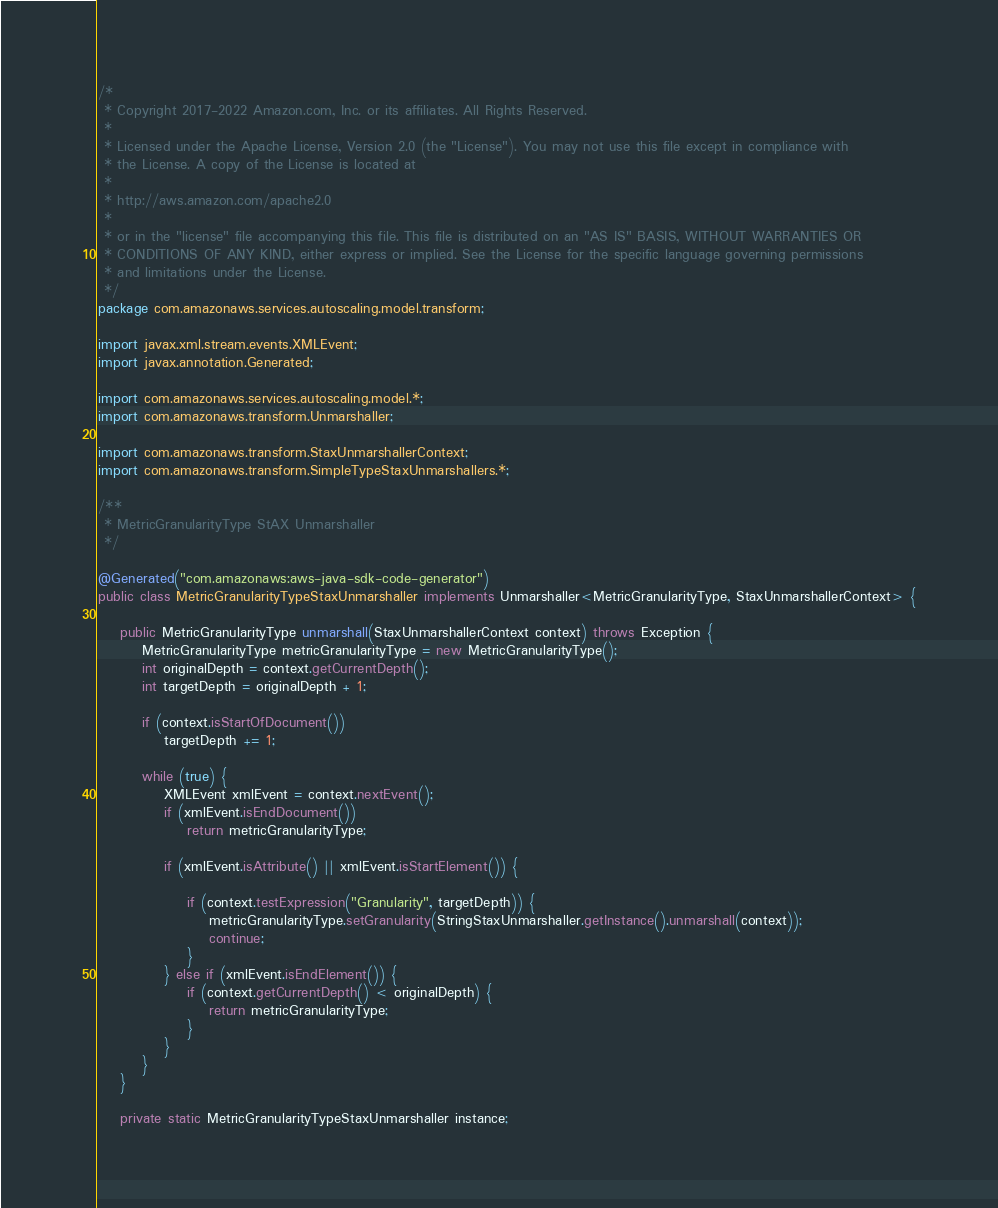Convert code to text. <code><loc_0><loc_0><loc_500><loc_500><_Java_>/*
 * Copyright 2017-2022 Amazon.com, Inc. or its affiliates. All Rights Reserved.
 * 
 * Licensed under the Apache License, Version 2.0 (the "License"). You may not use this file except in compliance with
 * the License. A copy of the License is located at
 * 
 * http://aws.amazon.com/apache2.0
 * 
 * or in the "license" file accompanying this file. This file is distributed on an "AS IS" BASIS, WITHOUT WARRANTIES OR
 * CONDITIONS OF ANY KIND, either express or implied. See the License for the specific language governing permissions
 * and limitations under the License.
 */
package com.amazonaws.services.autoscaling.model.transform;

import javax.xml.stream.events.XMLEvent;
import javax.annotation.Generated;

import com.amazonaws.services.autoscaling.model.*;
import com.amazonaws.transform.Unmarshaller;

import com.amazonaws.transform.StaxUnmarshallerContext;
import com.amazonaws.transform.SimpleTypeStaxUnmarshallers.*;

/**
 * MetricGranularityType StAX Unmarshaller
 */

@Generated("com.amazonaws:aws-java-sdk-code-generator")
public class MetricGranularityTypeStaxUnmarshaller implements Unmarshaller<MetricGranularityType, StaxUnmarshallerContext> {

    public MetricGranularityType unmarshall(StaxUnmarshallerContext context) throws Exception {
        MetricGranularityType metricGranularityType = new MetricGranularityType();
        int originalDepth = context.getCurrentDepth();
        int targetDepth = originalDepth + 1;

        if (context.isStartOfDocument())
            targetDepth += 1;

        while (true) {
            XMLEvent xmlEvent = context.nextEvent();
            if (xmlEvent.isEndDocument())
                return metricGranularityType;

            if (xmlEvent.isAttribute() || xmlEvent.isStartElement()) {

                if (context.testExpression("Granularity", targetDepth)) {
                    metricGranularityType.setGranularity(StringStaxUnmarshaller.getInstance().unmarshall(context));
                    continue;
                }
            } else if (xmlEvent.isEndElement()) {
                if (context.getCurrentDepth() < originalDepth) {
                    return metricGranularityType;
                }
            }
        }
    }

    private static MetricGranularityTypeStaxUnmarshaller instance;
</code> 